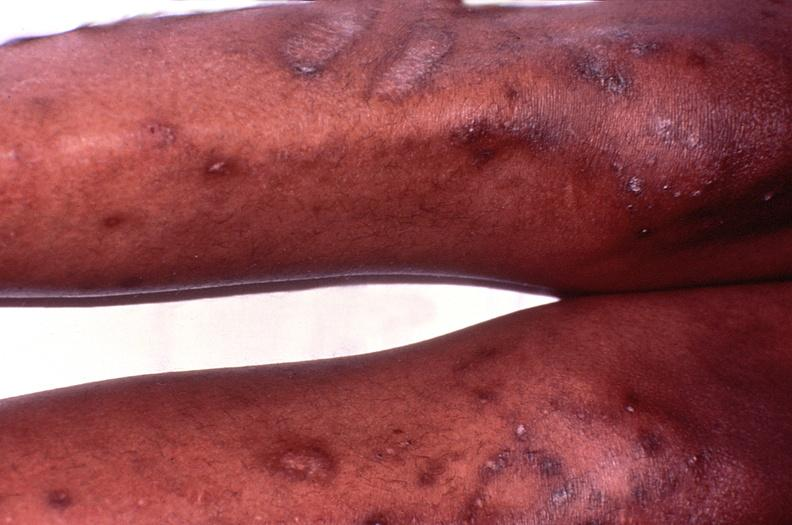does this image show cryptococcal dematitis?
Answer the question using a single word or phrase. Yes 